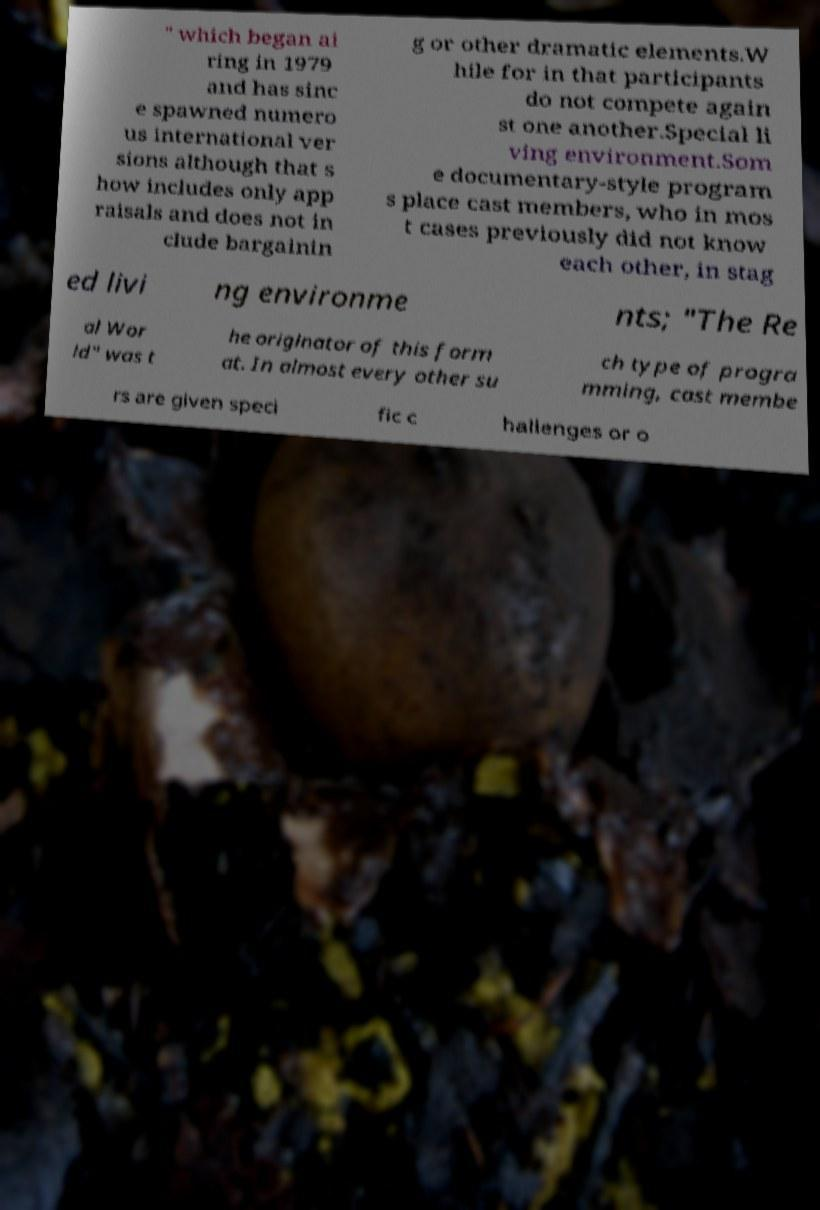Can you accurately transcribe the text from the provided image for me? " which began ai ring in 1979 and has sinc e spawned numero us international ver sions although that s how includes only app raisals and does not in clude bargainin g or other dramatic elements.W hile for in that participants do not compete again st one another.Special li ving environment.Som e documentary-style program s place cast members, who in mos t cases previously did not know each other, in stag ed livi ng environme nts; "The Re al Wor ld" was t he originator of this form at. In almost every other su ch type of progra mming, cast membe rs are given speci fic c hallenges or o 